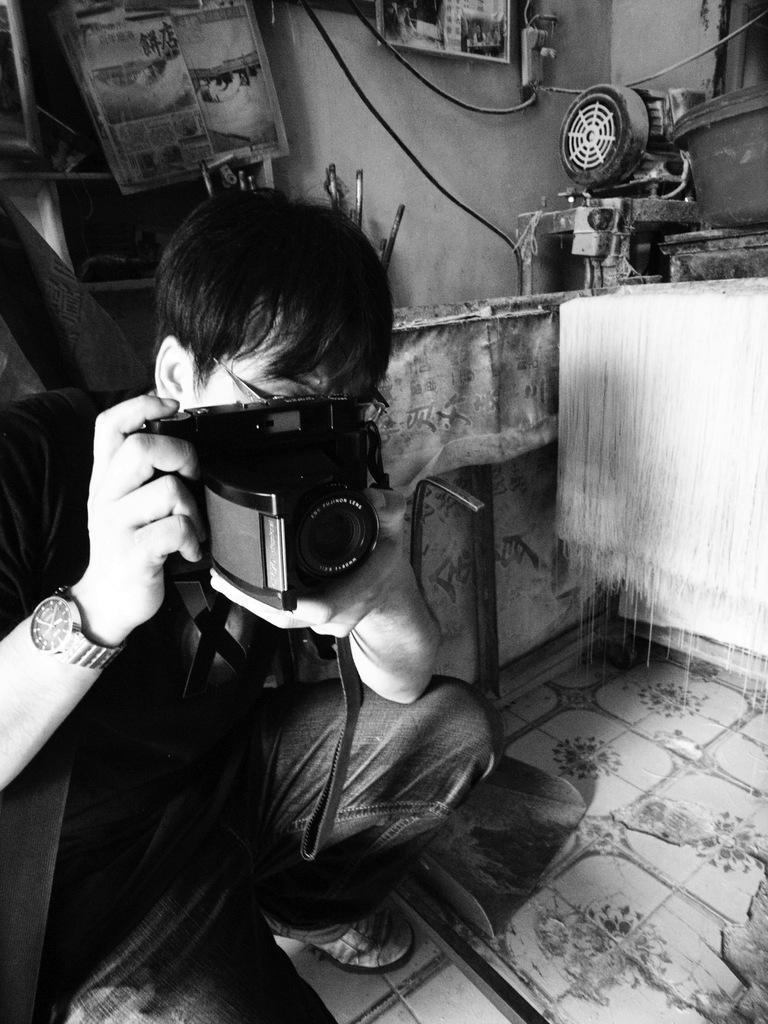In one or two sentences, can you explain what this image depicts? This is a black and white image, in this image there is a person holding a camera is clicking the picture, behind the person there are some objects on a platform and there are cables and there are some objects hanging on the wall, on the wall there are shelves with some objects in it. 